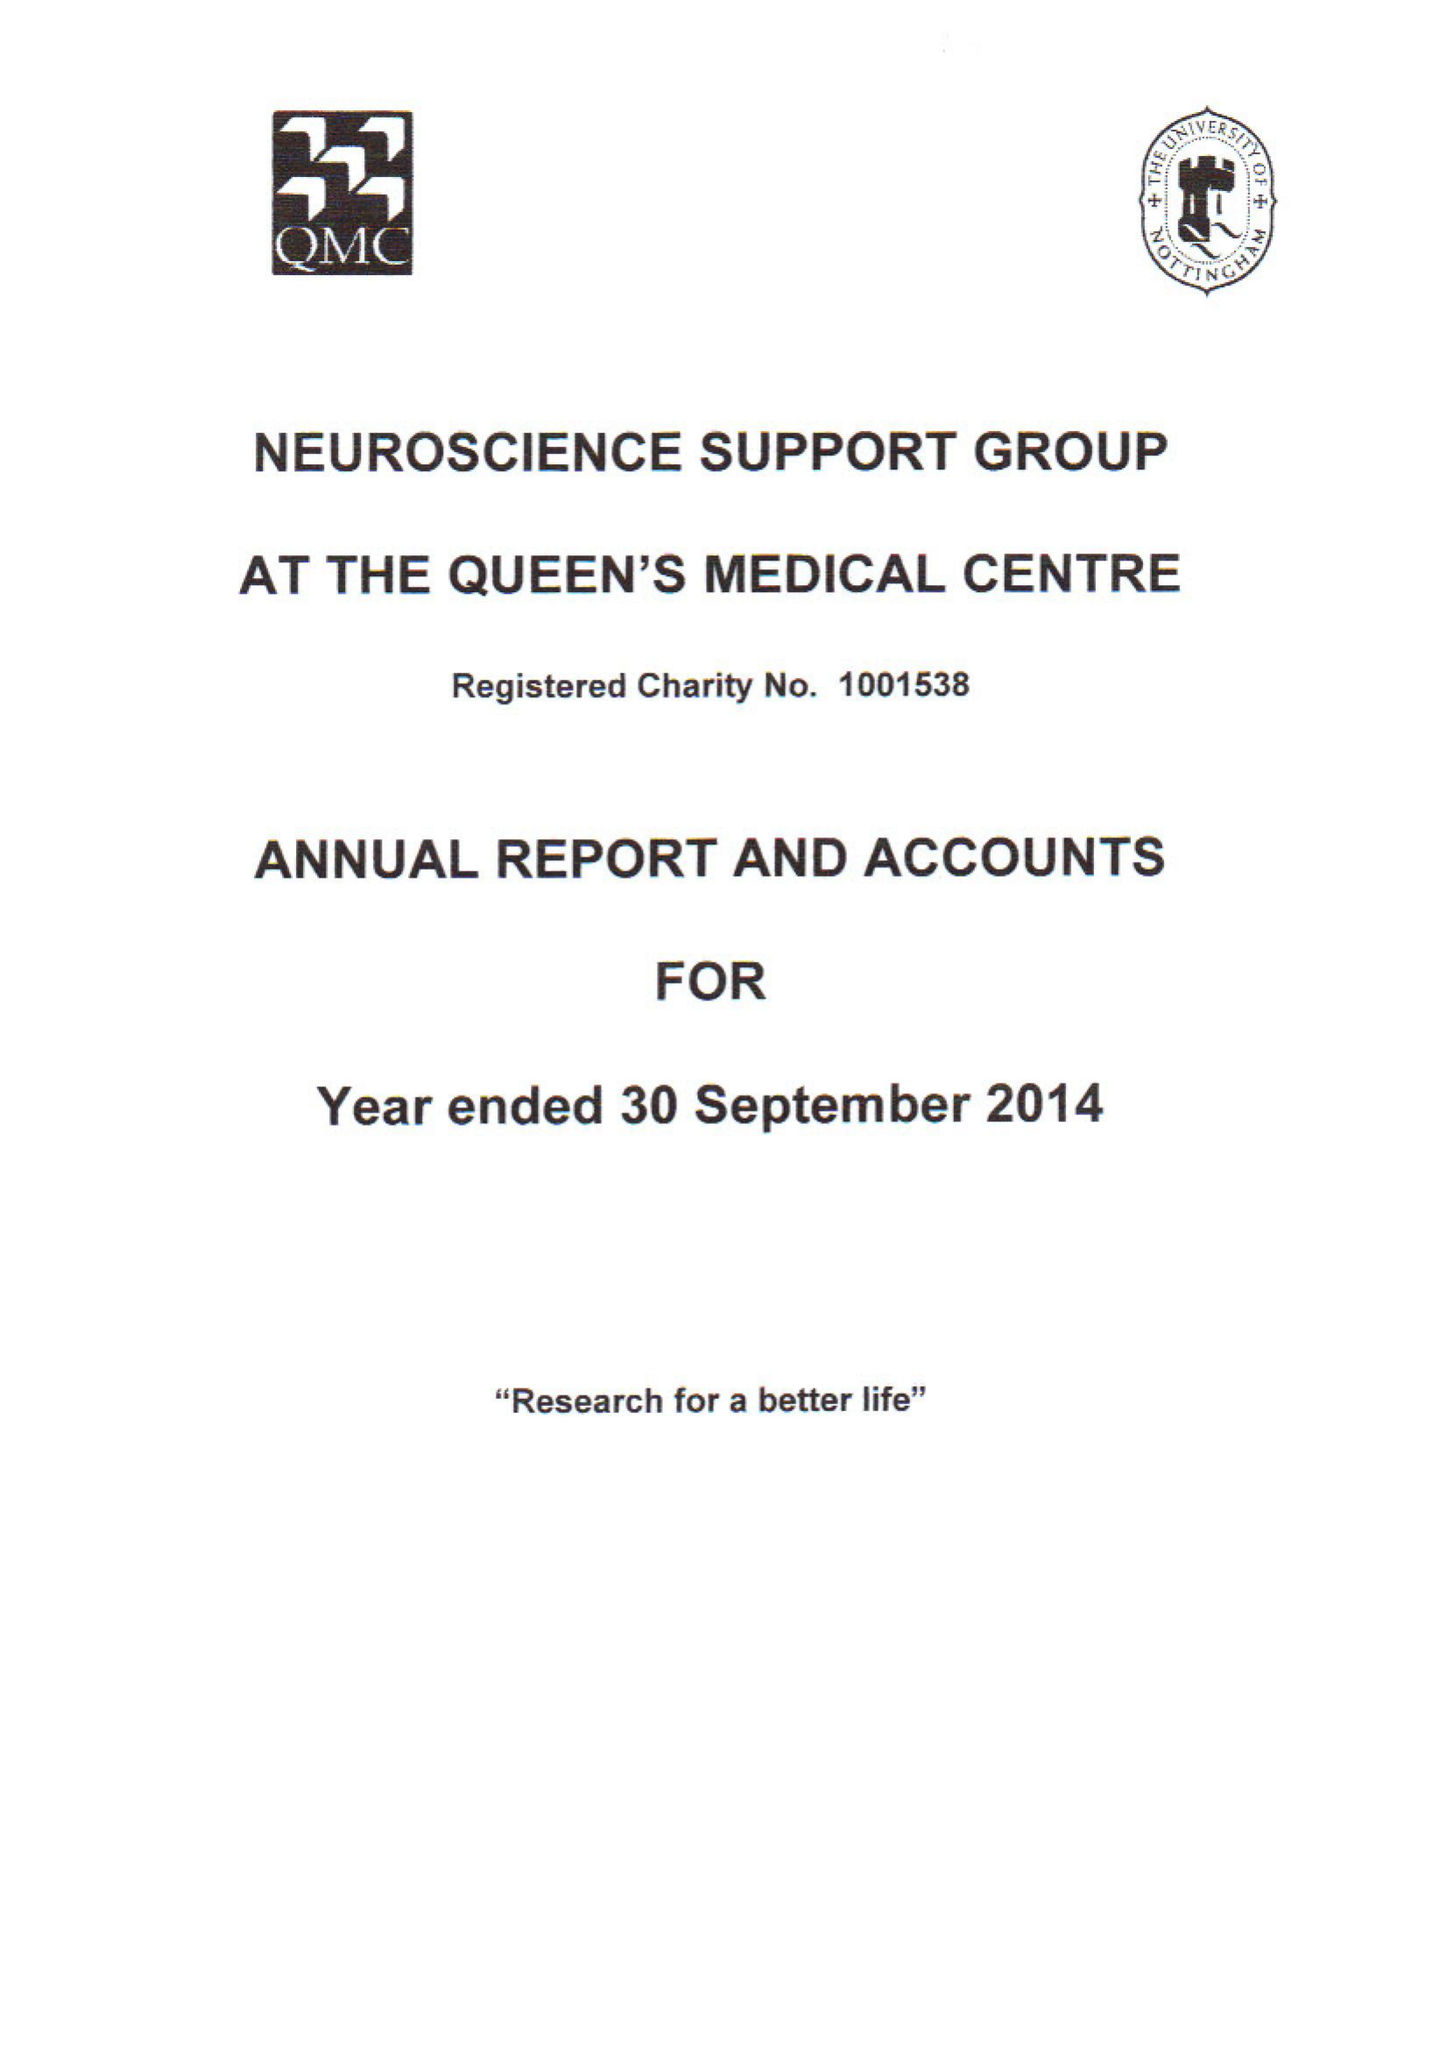What is the value for the report_date?
Answer the question using a single word or phrase. 2014-09-30 